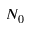Convert formula to latex. <formula><loc_0><loc_0><loc_500><loc_500>N _ { 0 }</formula> 